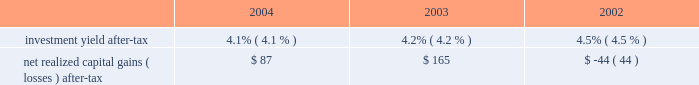Has decreased during the period from 2002 to 2004 , principally due to the increase in earned premium and due to cost containment measures undertaken by management .
In business insurance and personal lines , the expense ratio is expected to decrease further in 2005 , largely as a result of expected increases in earned premium .
In specialty commercial , the expense ratio is expected to increase slightly in 2005 due to changes in the business mix , most notably the company 2019s decision in the fourth quarter of 2004 to exit the multi-peril crop insurance program which will eliminate significant expense reimbursements from the specialty commercial segment .
Policyholder dividend ratio : the policyholder dividend ratio is the ratio of policyholder dividends to earned premium .
Combined ratio : the combined ratio is the sum of the loss and loss adjustment expense ratio , the expense ratio and the policyholder dividend ratio .
This ratio is a relative measurement that describes the related cost of losses and expense for every $ 100 of earned premiums .
A combined ratio below 100.0 demonstrates underwriting profit ; a combined ratio above 100.0 demonstrates underwriting losses .
The combined ratio has decreased from 2003 to 2004 primarily because of improvement in the expense ratio .
The combined ratio in 2005 could be significantly higher or lower than the 2004 combined ratio depending on the level of catastrophe losses , but will also be impacted by changes in pricing and an expected moderation in favorable loss cost trends .
Catastrophe ratio : the catastrophe ratio ( a component of the loss and loss adjustment expense ratio ) represents the ratio of catastrophe losses ( net of reinsurance ) to earned premiums .
A catastrophe is an event that causes $ 25 or more in industry insured property losses and affects a significant number of property and casualty policyholders and insurers .
By their nature , catastrophe losses vary dramatically from year to year .
Based on the mix and geographic dispersion of premium written and estimates derived from various catastrophe loss models , the company 2019s expected catastrophe ratio over the long-term is 3.0 points .
Before considering the reduction in ongoing operation 2019s catastrophe reserves related to september 11 of $ 298 in 2004 , the catastrophe ratio in 2004 was 5.3 points .
See 201crisk management strategy 201d below for a discussion of the company 2019s property catastrophe risk management program that serves to mitigate the company 2019s net exposure to catastrophe losses .
Combined ratio before catastrophes and prior accident year development : the combined ratio before catastrophes and prior accident year development represents the combined ratio for the current accident year , excluding the impact of catastrophes .
The company believes this ratio is an important measure of the trend in profitability since it removes the impact of volatile and unpredictable catastrophe losses and prior accident year reserve development .
Before considering catastrophes , the combined ratio related to current accident year business has improved from 2002 to 2004 principally due to earned pricing increases and favorable claim frequency .
Other operations underwriting results : the other operations segment is responsible for managing operations of the hartford that have discontinued writing new or renewal business as well as managing the claims related to asbestos and environmental exposures .
As such , neither earned premiums nor underwriting ratios are meaningful financial measures .
Instead , management believes that underwriting result is a more meaningful measure .
The net underwriting loss for 2002 through 2004 is primarily due to prior accident year loss development , including $ 2.6 billion of net asbestos reserve strengthening in 2003 .
Reserve estimates within other operations , including estimates for asbestos and environmental claims , are inherently uncertain .
Refer to the other operations segment md&a for further discussion of other operation's underwriting results .
Total property & casualty investment earnings .
The investment return , or yield , on property & casualty 2019s invested assets is an important element of the company 2019s earnings since insurance products are priced with the assumption that premiums received can be invested for a period of time before loss and loss adjustment expenses are paid .
For longer tail lines , such as workers 2019 compensation and general liability , claims are paid over several years and , therefore , the premiums received for these lines of business can generate significant investment income .
Him determines the appropriate allocation of investments by asset class and measures the investment yield performance for each asset class against market indices or other benchmarks .
Due to the emphasis on preservation of capital and the need to maintain sufficient liquidity to satisfy claim obligations , the vast majority of property and casualty 2019s invested assets have been held in fixed maturities , including , among other asset classes , corporate bonds , municipal bonds , government debt , short-term debt , mortgage- .
What was the average total property & casualty investment earnings net realized capital gains from 2002 to 2004? 
Computations: ((((87 + 165) + -44) + 3) / 2)
Answer: 105.5. 